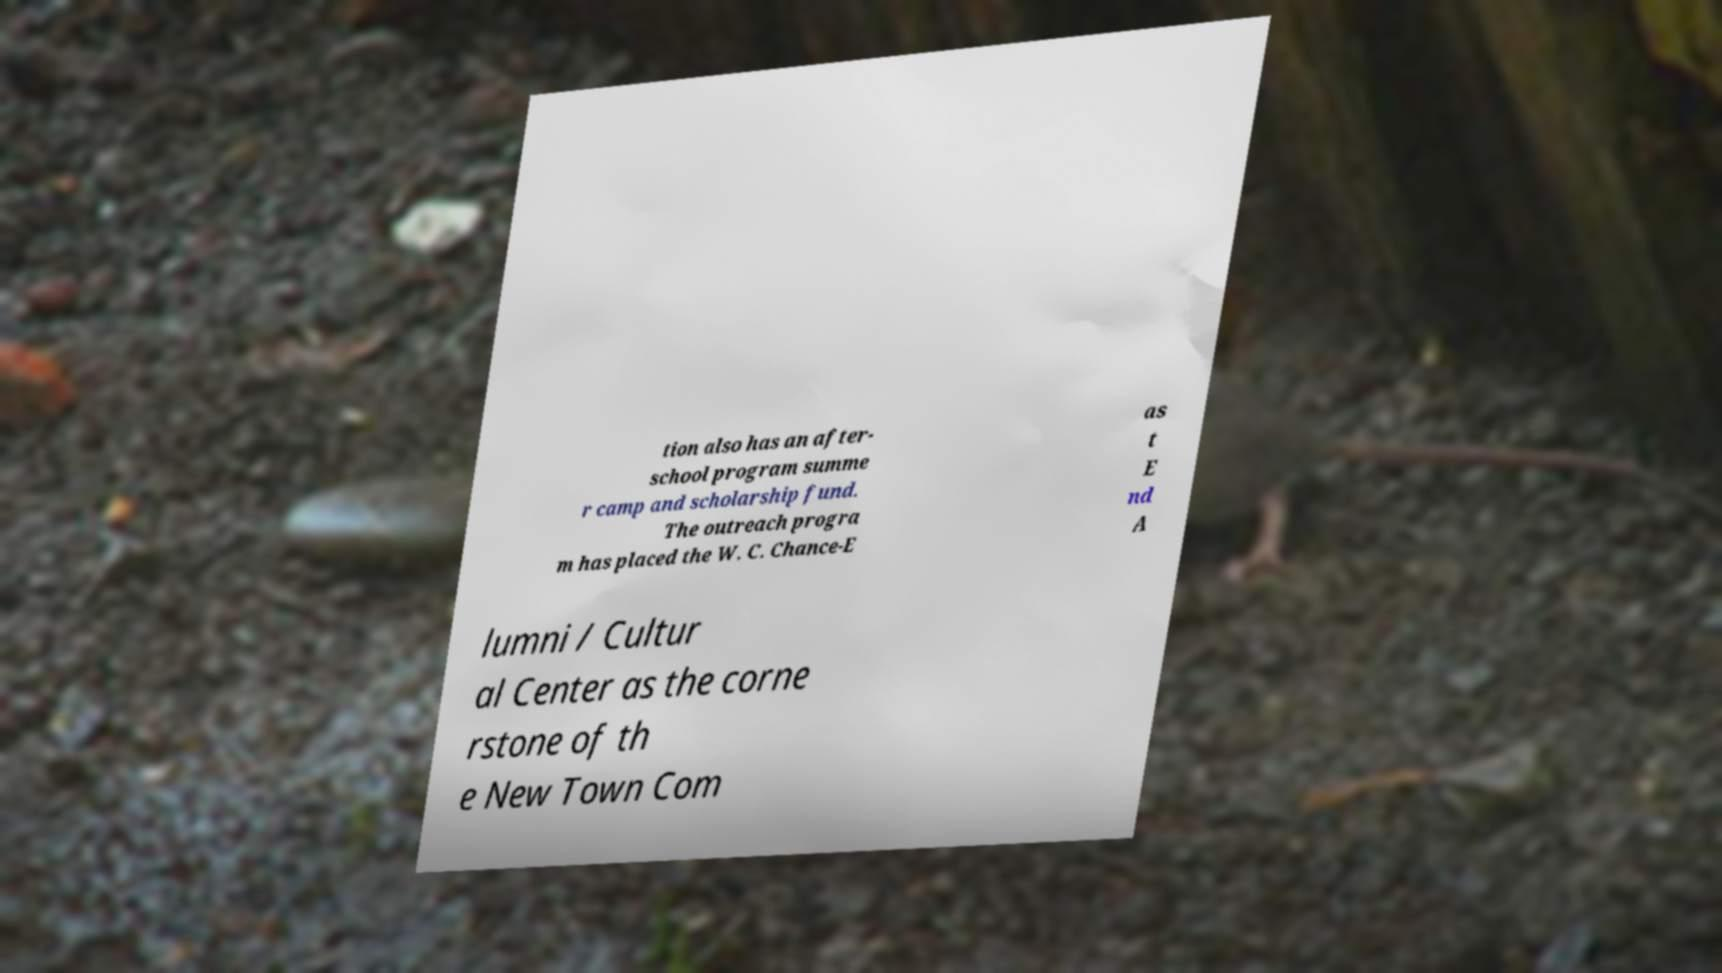There's text embedded in this image that I need extracted. Can you transcribe it verbatim? tion also has an after- school program summe r camp and scholarship fund. The outreach progra m has placed the W. C. Chance-E as t E nd A lumni / Cultur al Center as the corne rstone of th e New Town Com 